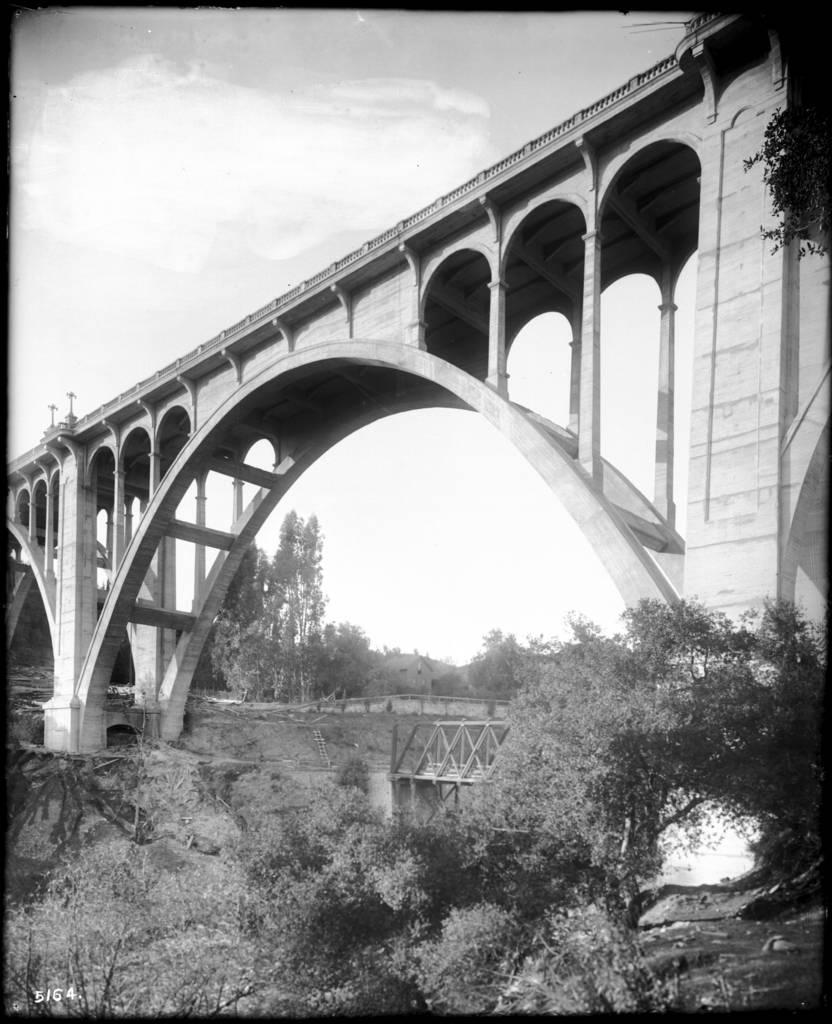What is the color scheme of the image? The image is black and white. What type of structure can be seen in the image? There is an arch bridge in the image. What other elements are present in the image besides the bridge? There are trees and plants in the image. What material is the bridge made of? The bridge appears to be made of wood. Can you see any geese swimming in the water under the bridge in the image? There is no water or geese present in the image; it features an arch bridge made of wood with trees and plants in the background. What type of beef is being cooked on the grill in the image? There is no grill or beef present in the image; it only shows an arch bridge, trees, and plants. 